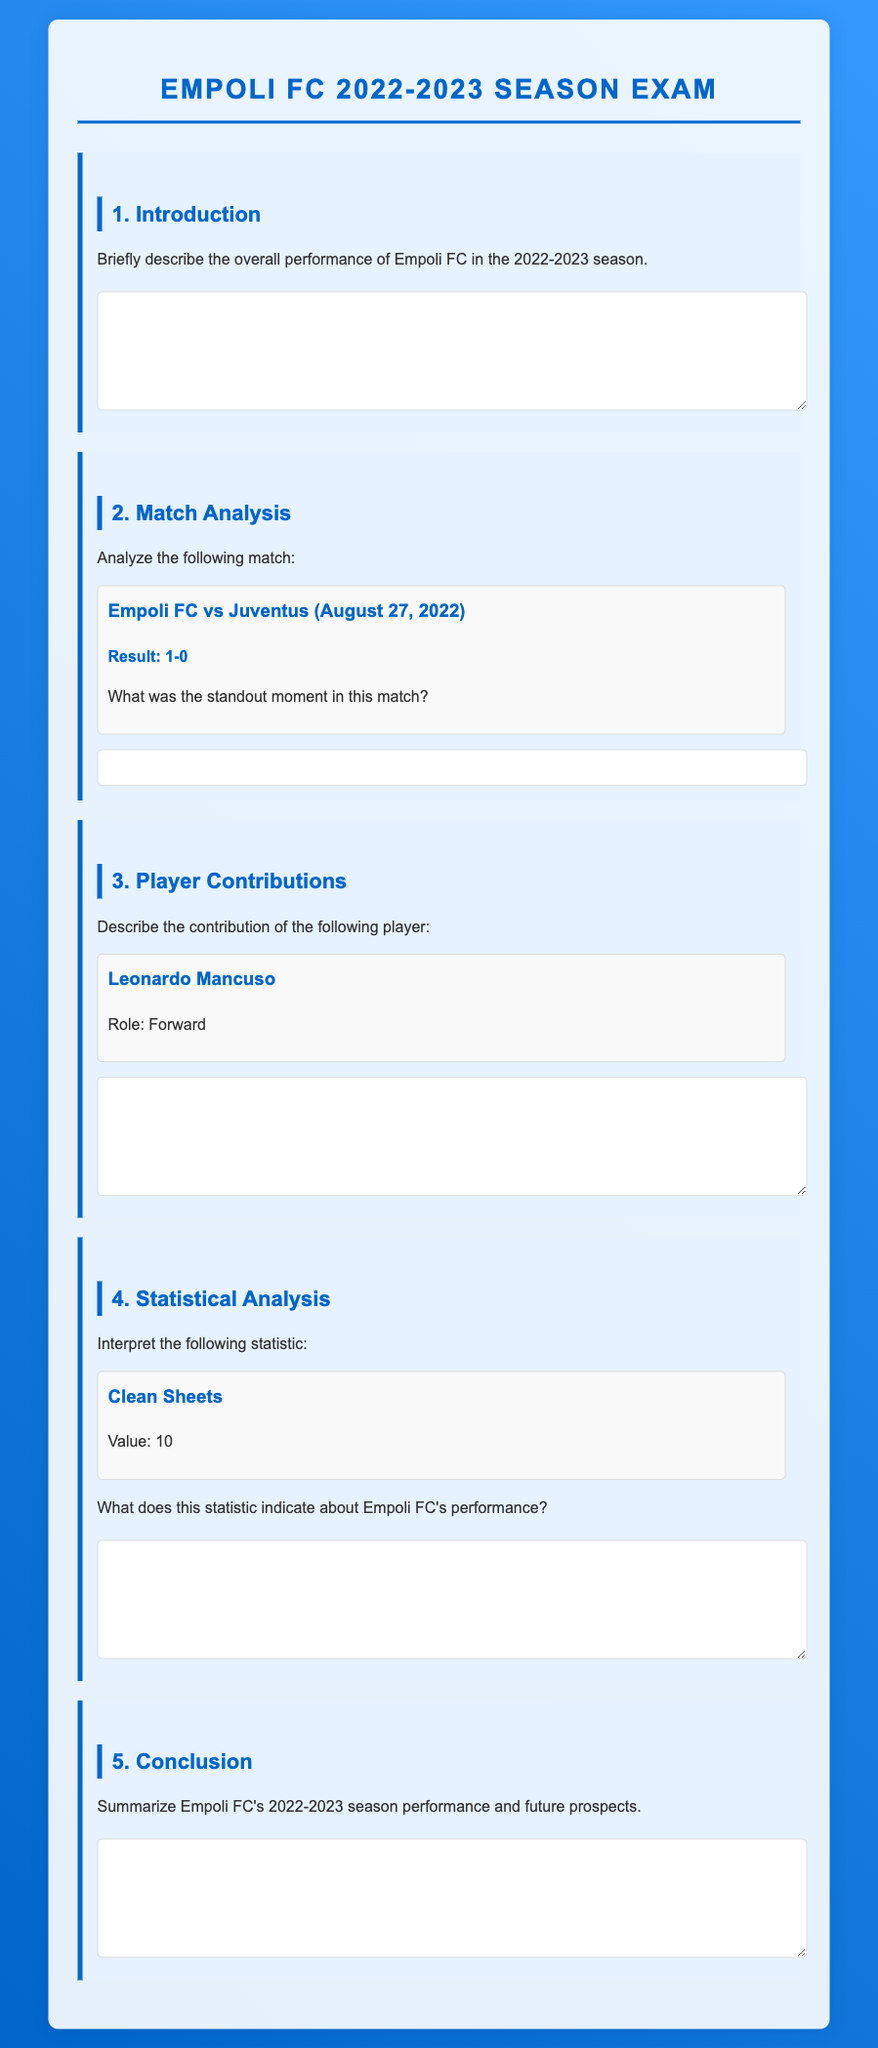What was the result of the match against Juventus? The result of the match against Juventus is specifically mentioned in the document as 1-0.
Answer: 1-0 Who was the forward player mentioned in the document? The document provides the name of the forward player as Leonardo Mancuso in the Player Contributions section.
Answer: Leonardo Mancuso How many clean sheets did Empoli FC have during the season? The document states that Empoli FC had a total of 10 clean sheets in the Statistical Analysis section.
Answer: 10 What key moment was requested for the match against Juventus? The document asks for a standout moment in the match against Juventus, indicating it was significant and noteworthy.
Answer: Standout moment What aspect of the season performance is analyzed in the Introduction section? The Introduction section is designed to provide a brief overview of the overall performance of Empoli FC during the season.
Answer: Overall performance What is the format of the document? The document is structured as an exam, including sections for introduction, match analysis, player contributions, statistical analysis, and conclusion.
Answer: Exam format What type of questions does the document primarily include? The questions in the document are primarily short-answer questions regarding performance, statistics, and contributions.
Answer: Short-answer questions 